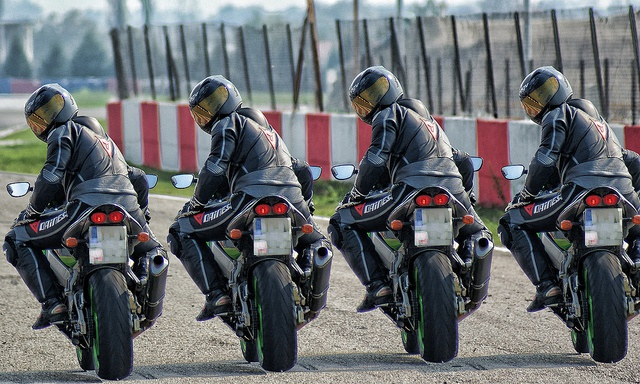Describe the objects in this image and their specific colors. I can see people in gray, black, darkgray, and navy tones, people in gray, black, darkgray, and navy tones, people in gray, black, darkgray, and navy tones, people in gray, black, darkgray, and navy tones, and motorcycle in gray, black, darkgray, and navy tones in this image. 